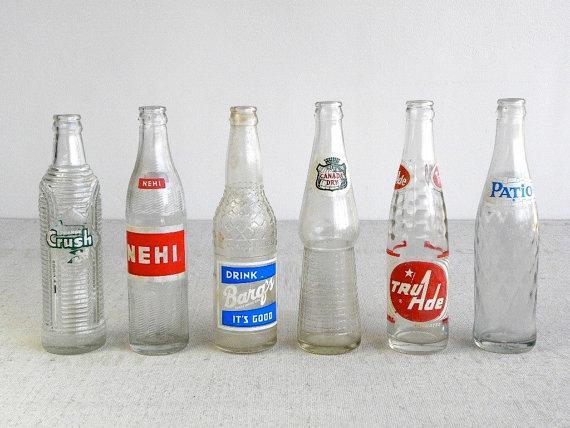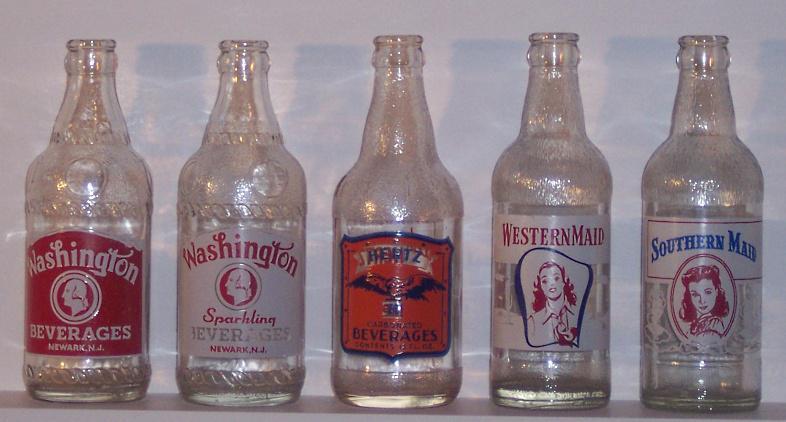The first image is the image on the left, the second image is the image on the right. Considering the images on both sides, is "The left image contains a staggered line of five glass bottles, and the right image contains a straighter row of four bottles." valid? Answer yes or no. No. The first image is the image on the left, the second image is the image on the right. Examine the images to the left and right. Is the description "There are four bottles in one image and five in the other." accurate? Answer yes or no. No. 